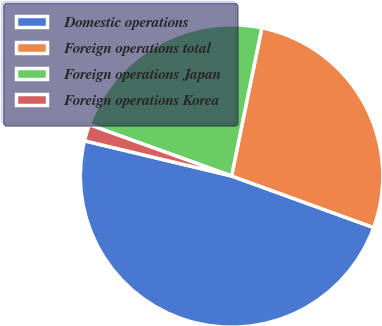Convert chart. <chart><loc_0><loc_0><loc_500><loc_500><pie_chart><fcel>Domestic operations<fcel>Foreign operations total<fcel>Foreign operations Japan<fcel>Foreign operations Korea<nl><fcel>48.19%<fcel>27.34%<fcel>22.7%<fcel>1.77%<nl></chart> 